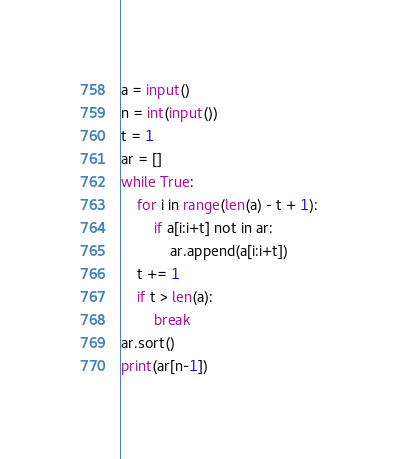<code> <loc_0><loc_0><loc_500><loc_500><_Python_>a = input()
n = int(input())
t = 1
ar = []
while True:
    for i in range(len(a) - t + 1):
        if a[i:i+t] not in ar:
            ar.append(a[i:i+t])
    t += 1
    if t > len(a):
        break
ar.sort()
print(ar[n-1])</code> 